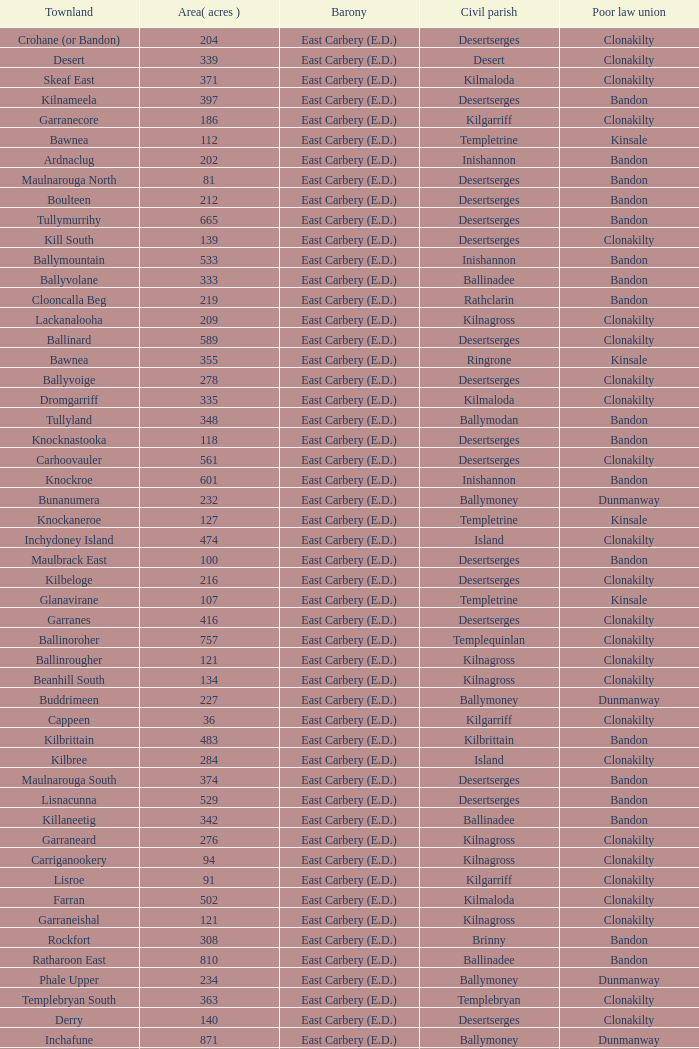What is the poor law union of the Lackenagobidane townland? Clonakilty. 